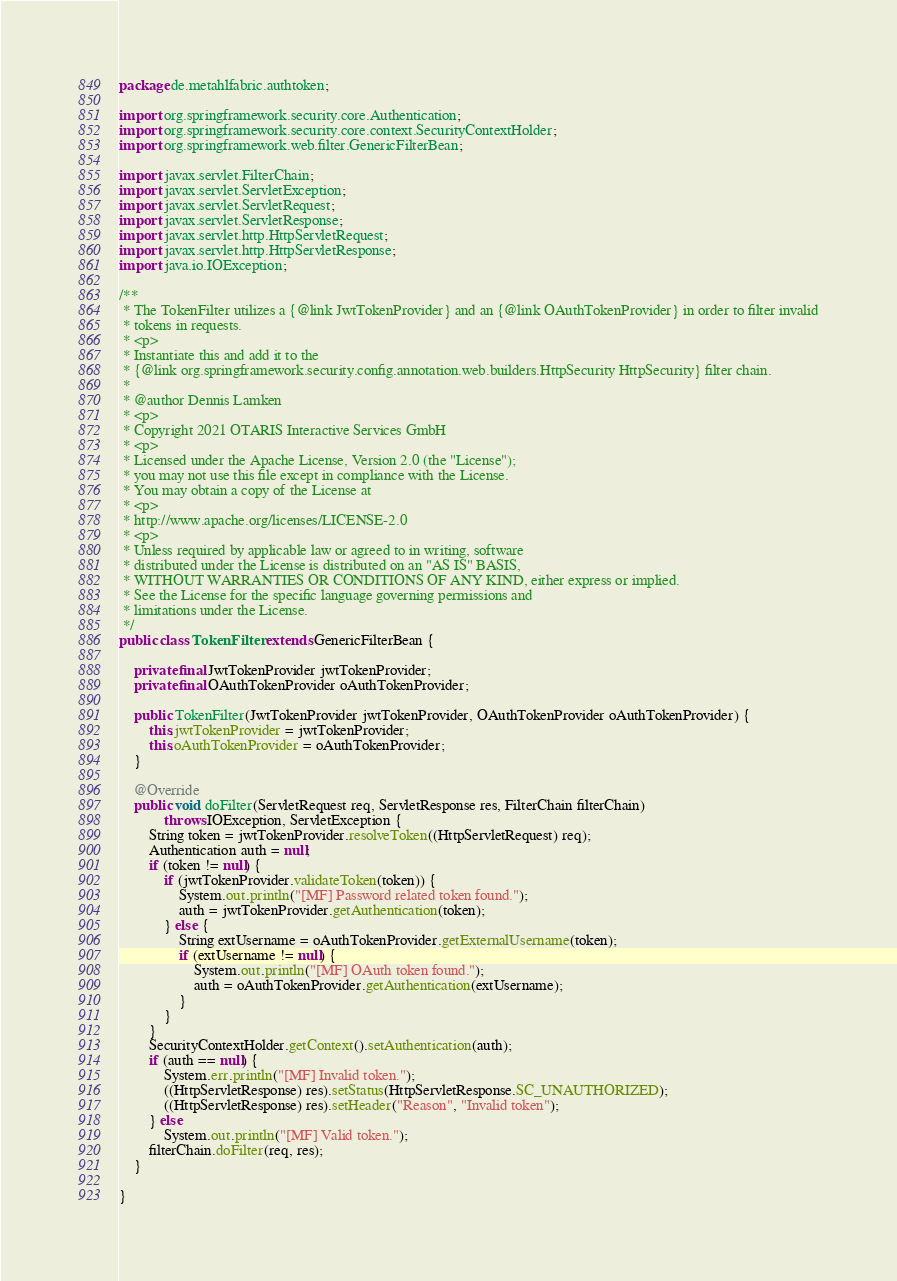Convert code to text. <code><loc_0><loc_0><loc_500><loc_500><_Java_>package de.metahlfabric.authtoken;

import org.springframework.security.core.Authentication;
import org.springframework.security.core.context.SecurityContextHolder;
import org.springframework.web.filter.GenericFilterBean;

import javax.servlet.FilterChain;
import javax.servlet.ServletException;
import javax.servlet.ServletRequest;
import javax.servlet.ServletResponse;
import javax.servlet.http.HttpServletRequest;
import javax.servlet.http.HttpServletResponse;
import java.io.IOException;

/**
 * The TokenFilter utilizes a {@link JwtTokenProvider} and an {@link OAuthTokenProvider} in order to filter invalid
 * tokens in requests.
 * <p>
 * Instantiate this and add it to the
 * {@link org.springframework.security.config.annotation.web.builders.HttpSecurity HttpSecurity} filter chain.
 *
 * @author Dennis Lamken
 * <p>
 * Copyright 2021 OTARIS Interactive Services GmbH
 * <p>
 * Licensed under the Apache License, Version 2.0 (the "License");
 * you may not use this file except in compliance with the License.
 * You may obtain a copy of the License at
 * <p>
 * http://www.apache.org/licenses/LICENSE-2.0
 * <p>
 * Unless required by applicable law or agreed to in writing, software
 * distributed under the License is distributed on an "AS IS" BASIS,
 * WITHOUT WARRANTIES OR CONDITIONS OF ANY KIND, either express or implied.
 * See the License for the specific language governing permissions and
 * limitations under the License.
 */
public class TokenFilter extends GenericFilterBean {

    private final JwtTokenProvider jwtTokenProvider;
    private final OAuthTokenProvider oAuthTokenProvider;

    public TokenFilter(JwtTokenProvider jwtTokenProvider, OAuthTokenProvider oAuthTokenProvider) {
        this.jwtTokenProvider = jwtTokenProvider;
        this.oAuthTokenProvider = oAuthTokenProvider;
    }

    @Override
    public void doFilter(ServletRequest req, ServletResponse res, FilterChain filterChain)
            throws IOException, ServletException {
        String token = jwtTokenProvider.resolveToken((HttpServletRequest) req);
        Authentication auth = null;
        if (token != null) {
            if (jwtTokenProvider.validateToken(token)) {
                System.out.println("[MF] Password related token found.");
                auth = jwtTokenProvider.getAuthentication(token);
            } else {
                String extUsername = oAuthTokenProvider.getExternalUsername(token);
                if (extUsername != null) {
                    System.out.println("[MF] OAuth token found.");
                    auth = oAuthTokenProvider.getAuthentication(extUsername);
                }
            }
        }
        SecurityContextHolder.getContext().setAuthentication(auth);
        if (auth == null) {
            System.err.println("[MF] Invalid token.");
            ((HttpServletResponse) res).setStatus(HttpServletResponse.SC_UNAUTHORIZED);
            ((HttpServletResponse) res).setHeader("Reason", "Invalid token");
        } else
            System.out.println("[MF] Valid token.");
        filterChain.doFilter(req, res);
    }

}</code> 